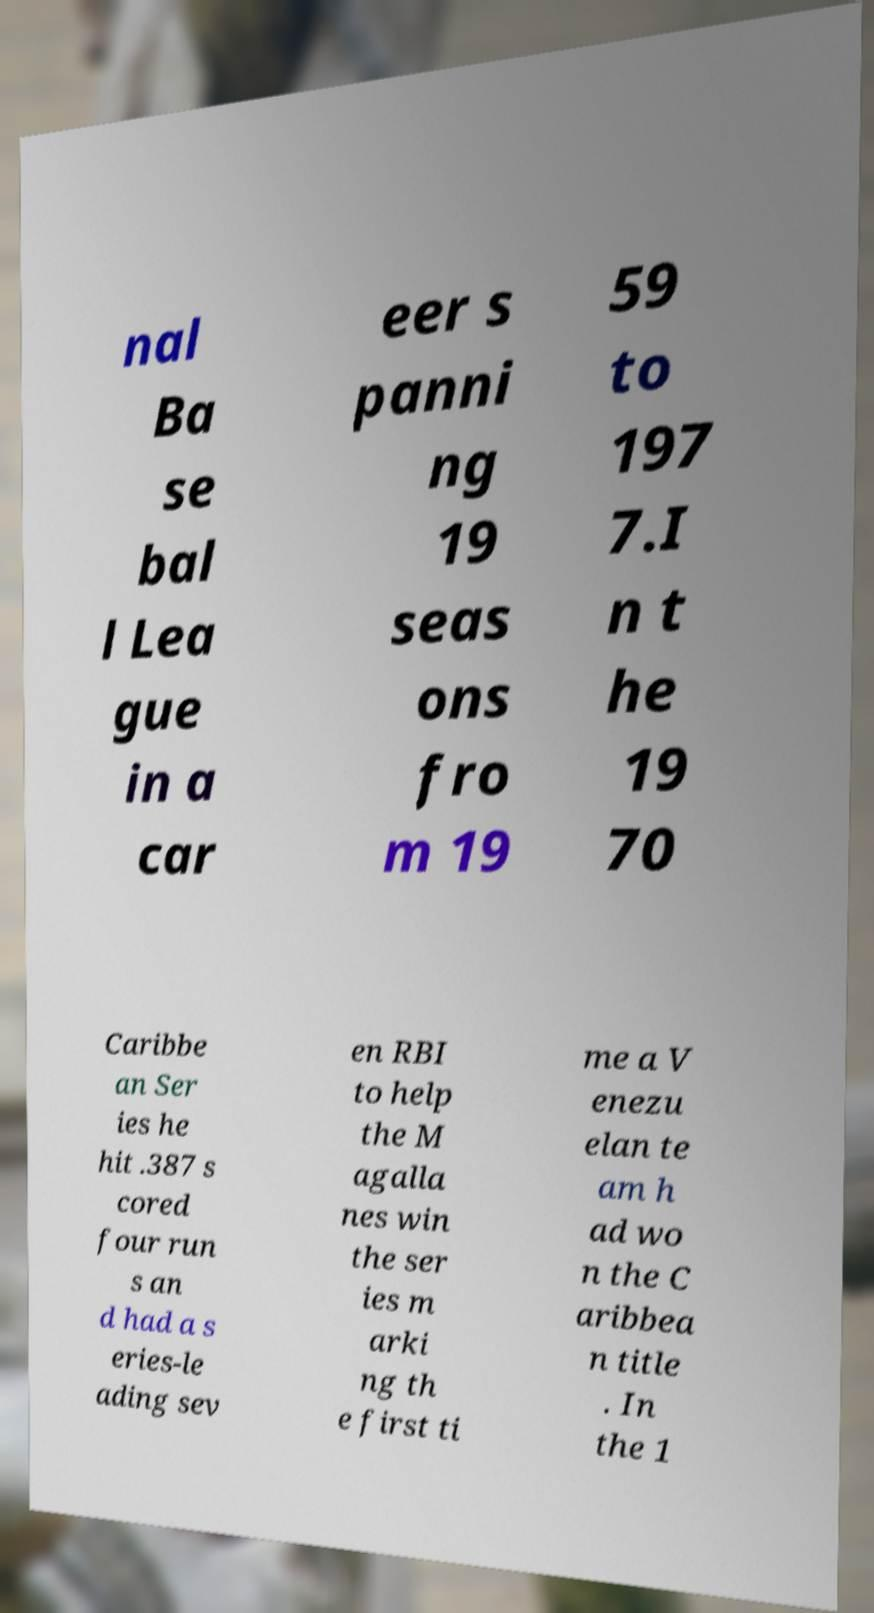There's text embedded in this image that I need extracted. Can you transcribe it verbatim? nal Ba se bal l Lea gue in a car eer s panni ng 19 seas ons fro m 19 59 to 197 7.I n t he 19 70 Caribbe an Ser ies he hit .387 s cored four run s an d had a s eries-le ading sev en RBI to help the M agalla nes win the ser ies m arki ng th e first ti me a V enezu elan te am h ad wo n the C aribbea n title . In the 1 